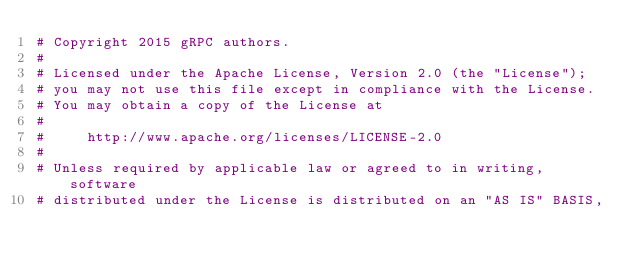<code> <loc_0><loc_0><loc_500><loc_500><_Cython_># Copyright 2015 gRPC authors.
#
# Licensed under the Apache License, Version 2.0 (the "License");
# you may not use this file except in compliance with the License.
# You may obtain a copy of the License at
#
#     http://www.apache.org/licenses/LICENSE-2.0
#
# Unless required by applicable law or agreed to in writing, software
# distributed under the License is distributed on an "AS IS" BASIS,</code> 